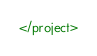<code> <loc_0><loc_0><loc_500><loc_500><_XML_></project>

</code> 